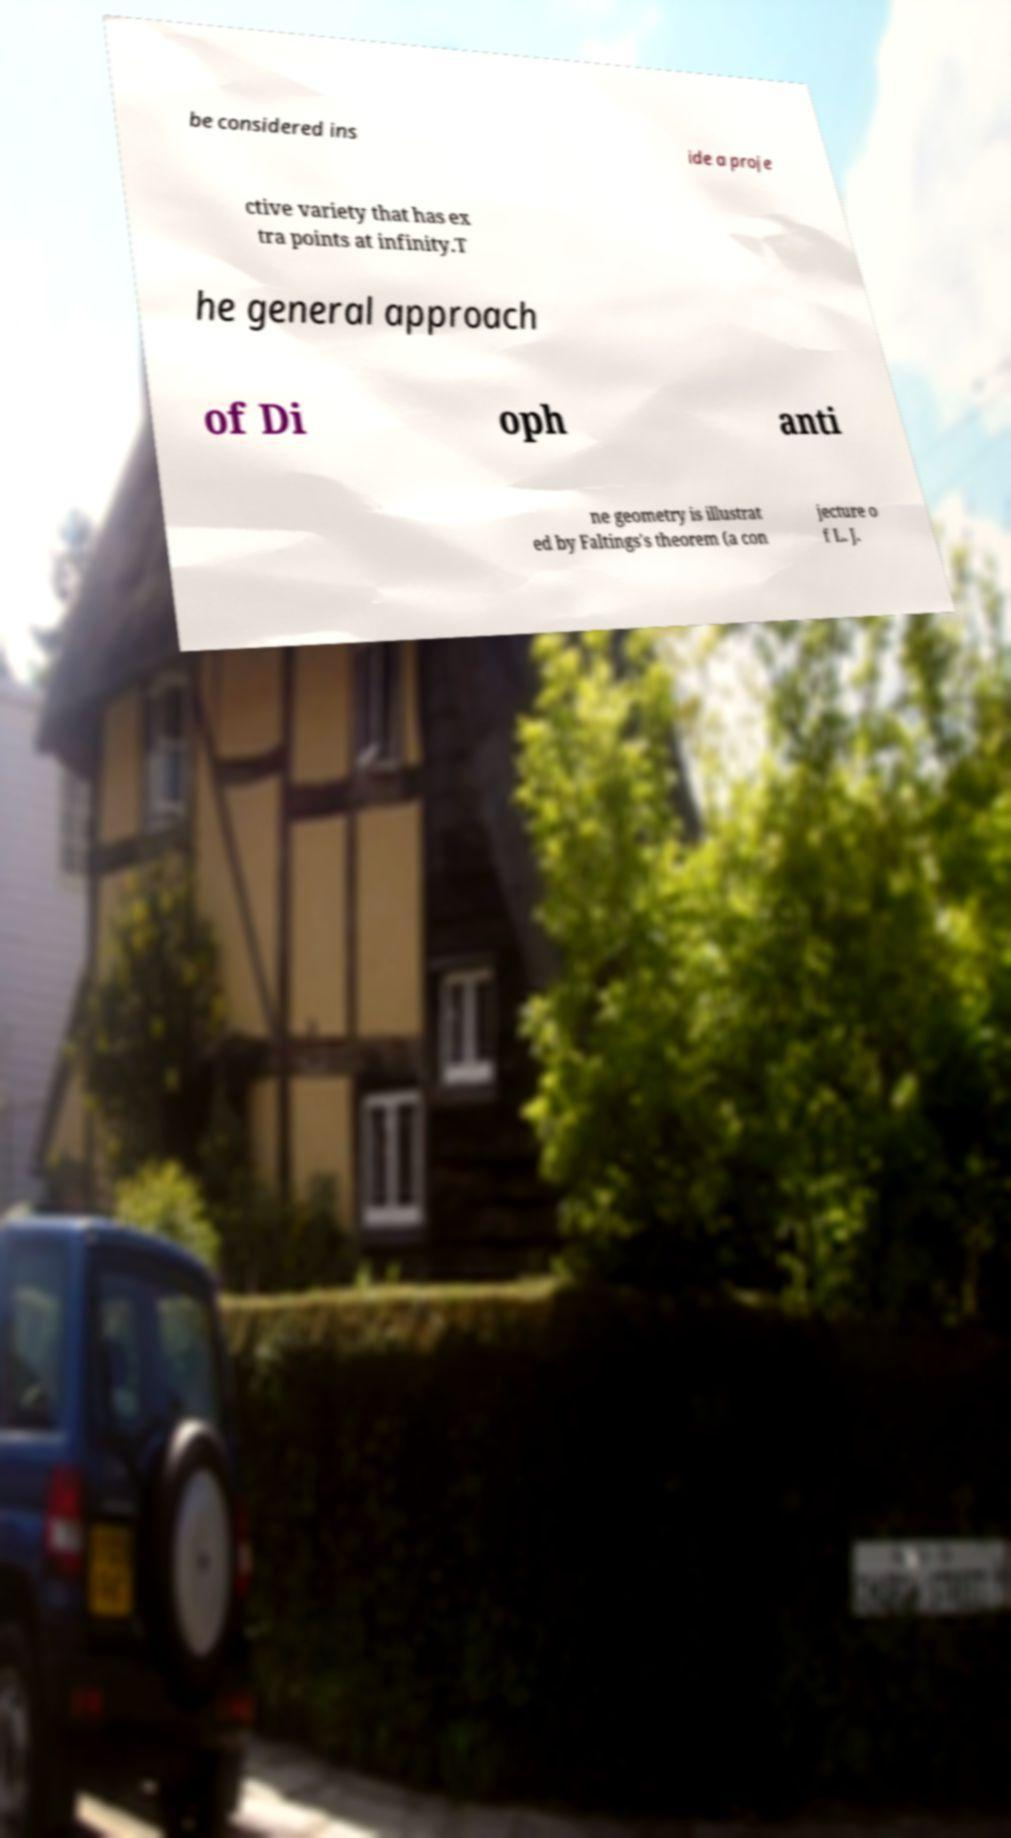Please identify and transcribe the text found in this image. be considered ins ide a proje ctive variety that has ex tra points at infinity.T he general approach of Di oph anti ne geometry is illustrat ed by Faltings's theorem (a con jecture o f L. J. 